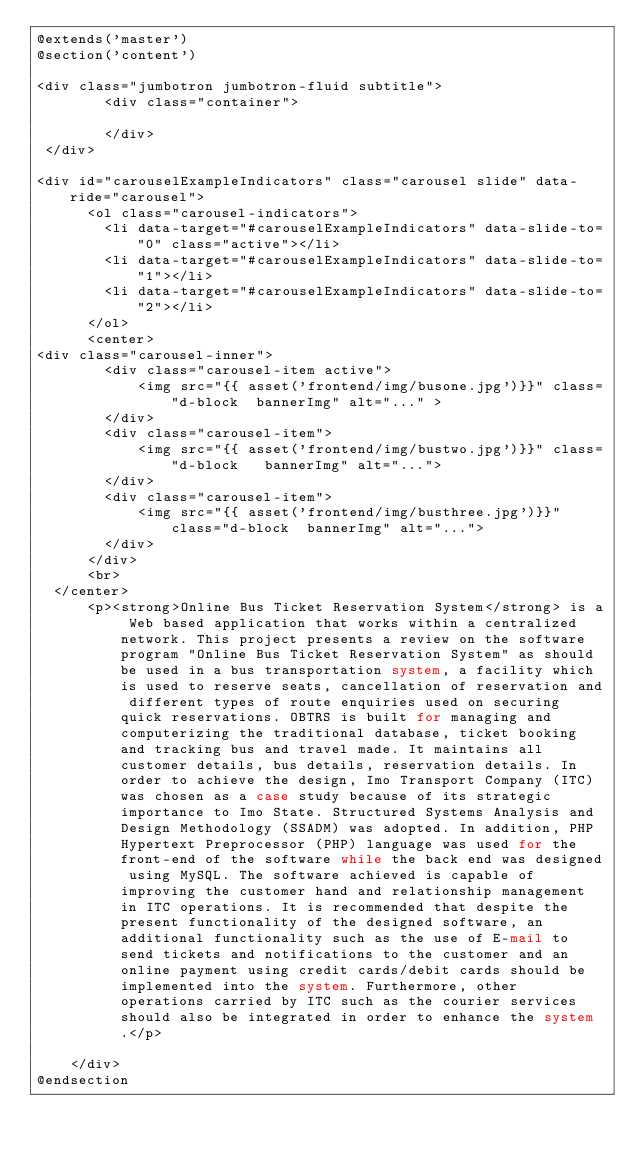<code> <loc_0><loc_0><loc_500><loc_500><_PHP_>@extends('master')
@section('content')

<div class="jumbotron jumbotron-fluid subtitle">
        <div class="container">
            
        </div>
 </div>

<div id="carouselExampleIndicators" class="carousel slide" data-ride="carousel">
      <ol class="carousel-indicators">
        <li data-target="#carouselExampleIndicators" data-slide-to="0" class="active"></li>
        <li data-target="#carouselExampleIndicators" data-slide-to="1"></li>
        <li data-target="#carouselExampleIndicators" data-slide-to="2"></li>
      </ol>
      <center>
<div class="carousel-inner">
        <div class="carousel-item active">
            <img src="{{ asset('frontend/img/busone.jpg')}}" class="d-block  bannerImg" alt="..." >
        </div>
        <div class="carousel-item">
            <img src="{{ asset('frontend/img/bustwo.jpg')}}" class="d-block   bannerImg" alt="...">
        </div>
        <div class="carousel-item">
            <img src="{{ asset('frontend/img/busthree.jpg')}}" class="d-block  bannerImg" alt="...">
        </div>
      </div>
      <br>
  </center>
      <p><strong>Online Bus Ticket Reservation System</strong> is a Web based application that works within a centralized network. This project presents a review on the software program "Online Bus Ticket Reservation System" as should be used in a bus transportation system, a facility which is used to reserve seats, cancellation of reservation and different types of route enquiries used on securing quick reservations. OBTRS is built for managing and computerizing the traditional database, ticket booking and tracking bus and travel made. It maintains all customer details, bus details, reservation details. In order to achieve the design, Imo Transport Company (ITC) was chosen as a case study because of its strategic importance to Imo State. Structured Systems Analysis and Design Methodology (SSADM) was adopted. In addition, PHP Hypertext Preprocessor (PHP) language was used for the front-end of the software while the back end was designed using MySQL. The software achieved is capable of improving the customer hand and relationship management in ITC operations. It is recommended that despite the present functionality of the designed software, an additional functionality such as the use of E-mail to send tickets and notifications to the customer and an online payment using credit cards/debit cards should be implemented into the system. Furthermore, other operations carried by ITC such as the courier services should also be integrated in order to enhance the system.</p>

    </div>
@endsection</code> 